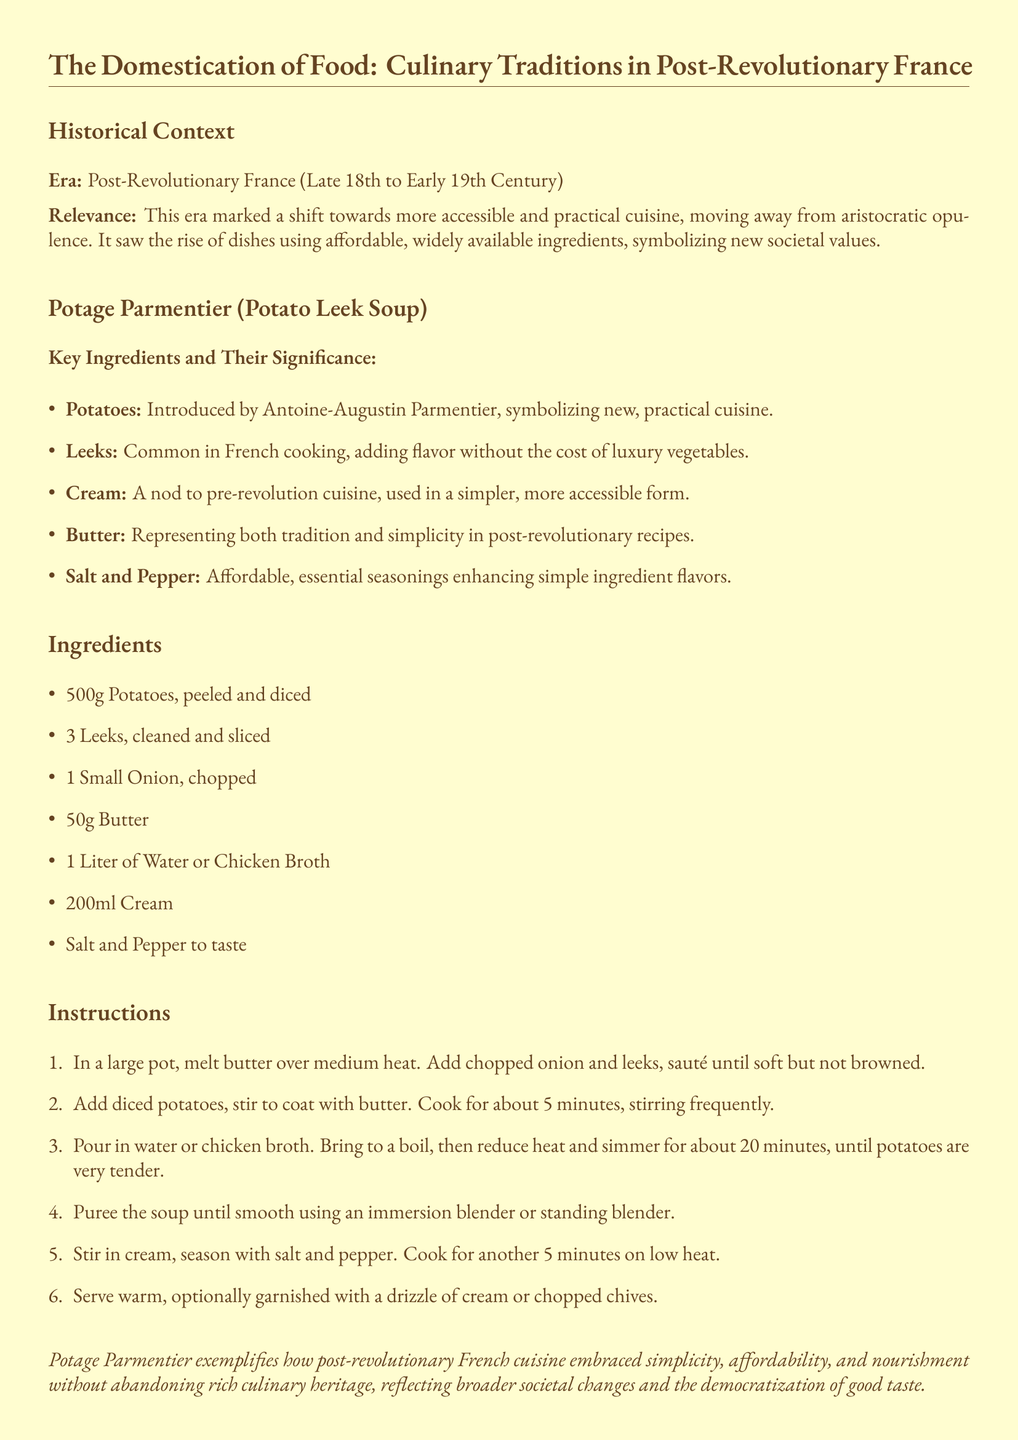What era does the document cover? The historical context section specifies the era as Post-Revolutionary France, which is indicated in the title.
Answer: Post-Revolutionary France Who introduced potatoes to French cuisine? The key ingredients section attributes the introduction of potatoes to Antoine-Augustin Parmentier.
Answer: Antoine-Augustin Parmentier What is the main vegetable in Potage Parmentier? The ingredients list prominently mentions potatoes as the main vegetable for the soup.
Answer: Potatoes How many leeks are needed for the recipe? The ingredients list specifies that 3 leeks are required for the soup.
Answer: 3 What cooking method is used for the soup? The instructions detail pureeing the soup after it has been cooked, indicating a blending method.
Answer: Puree What does the recipe symbolize regarding societal values? The description indicates that the recipe represents a shift towards accessible and practical cuisine.
Answer: New societal values What is a potential garnish for the soup? The instructions mention garnishing the soup with chopped chives or a drizzle of cream.
Answer: Chopped chives What historical significance does the document ascribe to Potage Parmentier? The document describes the soup as an example of simplicity, affordability, and nourishment in post-revolutionary cuisine.
Answer: Embraced simplicity, affordability, and nourishment How much cream is required for the recipe? The ingredients section states that 200ml of cream is needed for the soup.
Answer: 200ml 